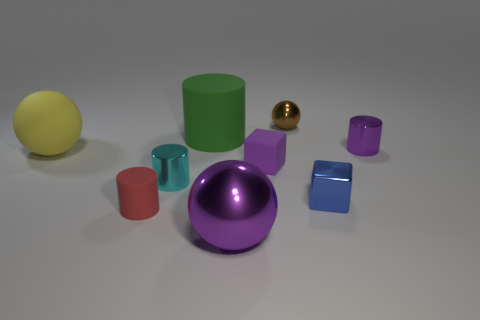Subtract all cyan shiny cylinders. How many cylinders are left? 3 Subtract 2 cylinders. How many cylinders are left? 2 Subtract all purple cylinders. How many cylinders are left? 3 Subtract all cubes. How many objects are left? 7 Subtract all blue cylinders. Subtract all green balls. How many cylinders are left? 4 Subtract all tiny blue metal cubes. Subtract all small brown spheres. How many objects are left? 7 Add 4 big green objects. How many big green objects are left? 5 Add 4 purple spheres. How many purple spheres exist? 5 Subtract 0 gray blocks. How many objects are left? 9 